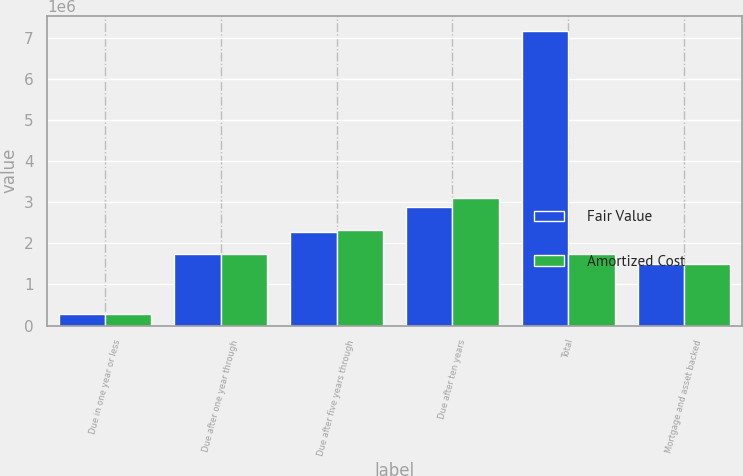Convert chart. <chart><loc_0><loc_0><loc_500><loc_500><stacked_bar_chart><ecel><fcel>Due in one year or less<fcel>Due after one year through<fcel>Due after five years through<fcel>Due after ten years<fcel>Total<fcel>Mortgage and asset backed<nl><fcel>Fair Value<fcel>285576<fcel>1.72785e+06<fcel>2.28537e+06<fcel>2.87203e+06<fcel>7.17083e+06<fcel>1.49777e+06<nl><fcel>Amortized Cost<fcel>287038<fcel>1.73884e+06<fcel>2.3347e+06<fcel>3.10852e+06<fcel>1.73884e+06<fcel>1.49268e+06<nl></chart> 